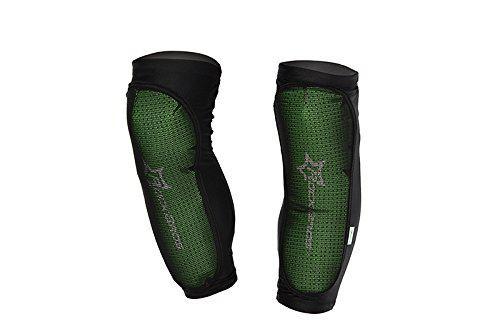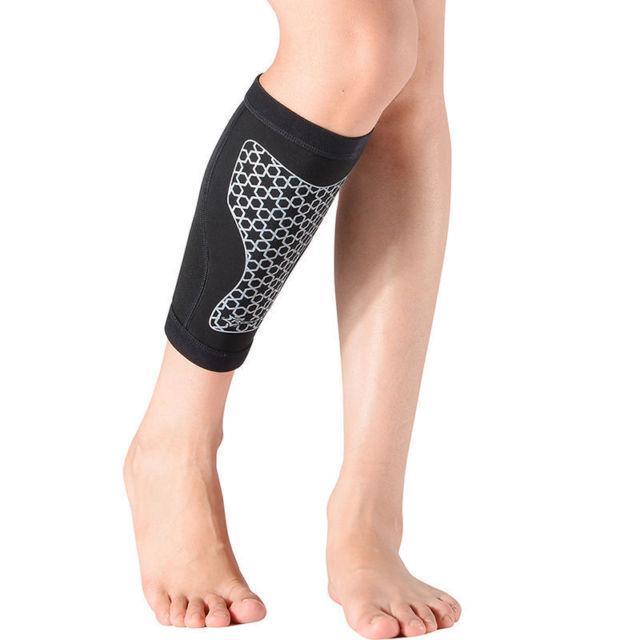The first image is the image on the left, the second image is the image on the right. Assess this claim about the two images: "There are two pairs of legs and two pairs of leg braces.". Correct or not? Answer yes or no. No. 